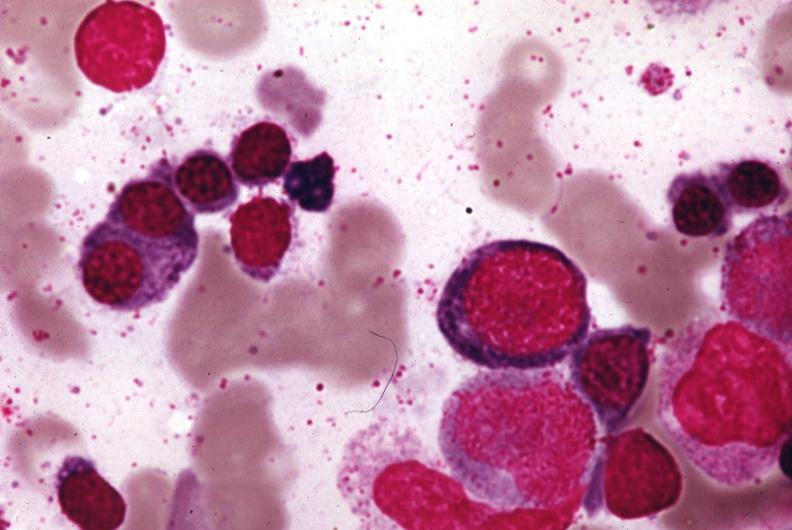s metastatic carcinoma x-ray present?
Answer the question using a single word or phrase. No 